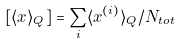Convert formula to latex. <formula><loc_0><loc_0><loc_500><loc_500>[ \langle x \rangle _ { Q } ] = \sum _ { i } \langle x ^ { ( i ) } \rangle _ { Q } / N _ { t o t }</formula> 